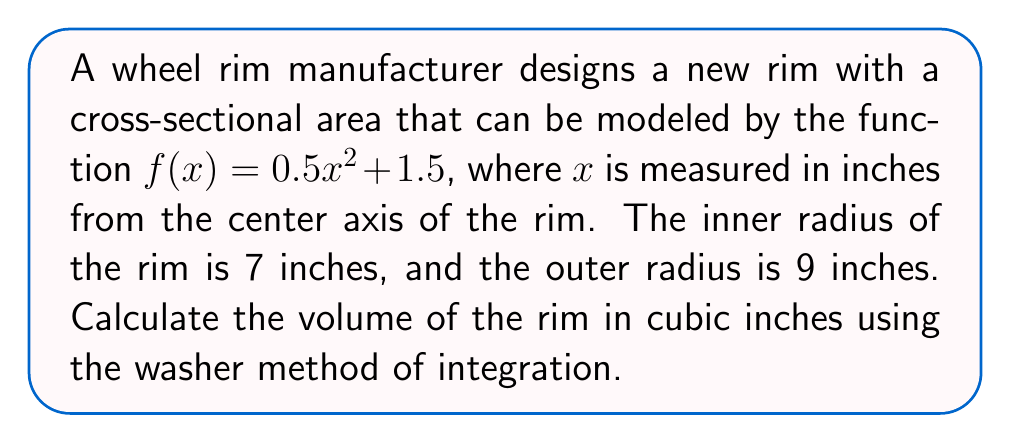Could you help me with this problem? To solve this problem, we'll use the washer method of integration, which is ideal for finding the volume of a solid of revolution. Here's the step-by-step solution:

1) The washer method formula for volume is:

   $$V = \pi \int_a^b [R(x)^2 - r(x)^2] dx$$

   where $R(x)$ is the outer radius function and $r(x)$ is the inner radius function.

2) In this case, we're rotating the function $f(x) = 0.5x^2 + 1.5$ around the x-axis from x = 7 to x = 9.

3) The outer radius function $R(x)$ is our given function:
   
   $$R(x) = f(x) = 0.5x^2 + 1.5$$

4) The inner radius function $r(x)$ is simply x, as we're measuring from the center axis:

   $$r(x) = x$$

5) Substituting into our volume formula:

   $$V = \pi \int_7^9 [(0.5x^2 + 1.5)^2 - x^2] dx$$

6) Expanding the squared term:

   $$V = \pi \int_7^9 [(0.25x^4 + 1.5x^2 + 2.25) - x^2] dx$$

7) Simplifying:

   $$V = \pi \int_7^9 [0.25x^4 + 0.5x^2 + 2.25] dx$$

8) Integrating:

   $$V = \pi [\frac{0.25x^5}{5} + \frac{0.5x^3}{3} + 2.25x]_7^9$$

9) Evaluating the definite integral:

   $$V = \pi [(\frac{0.25(9^5)}{5} + \frac{0.5(9^3)}{3} + 2.25(9)) - (\frac{0.25(7^5)}{5} + \frac{0.5(7^3)}{3} + 2.25(7))]$$

10) Calculating:

    $$V = \pi [364.5 - 137.9]$$
    $$V = \pi (226.6)$$
    $$V \approx 711.9 \text{ cubic inches}$$
Answer: The volume of the wheel rim is approximately 711.9 cubic inches. 